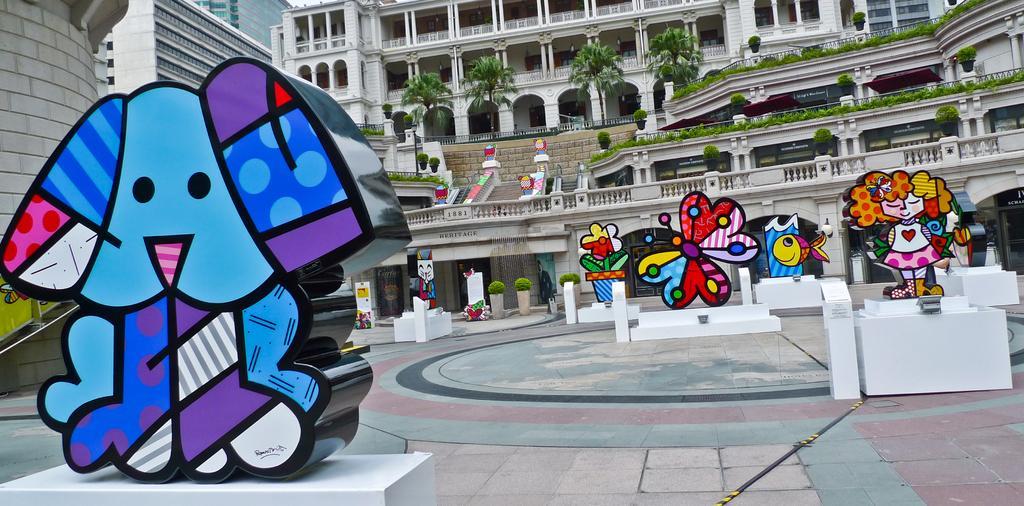Could you give a brief overview of what you see in this image? In this picture we can see the floor, statues on pedestals, plants, trees, buildings and some objects. 